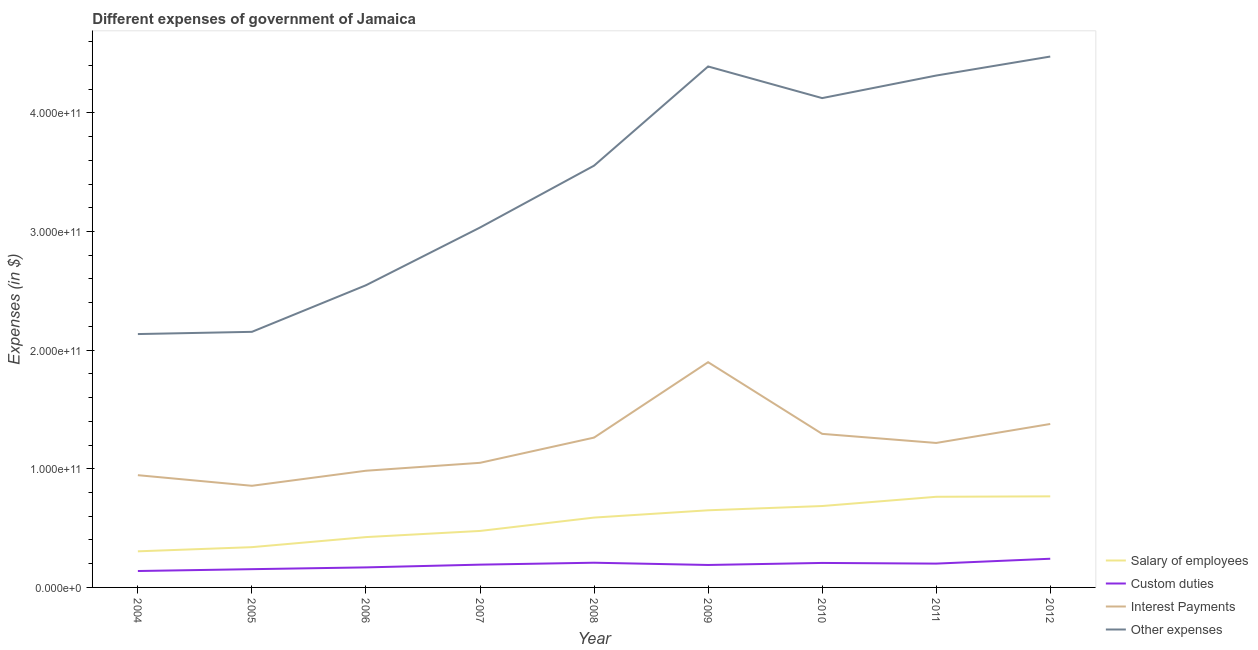Does the line corresponding to amount spent on other expenses intersect with the line corresponding to amount spent on salary of employees?
Provide a succinct answer. No. Is the number of lines equal to the number of legend labels?
Provide a succinct answer. Yes. What is the amount spent on interest payments in 2008?
Provide a succinct answer. 1.26e+11. Across all years, what is the maximum amount spent on custom duties?
Provide a succinct answer. 2.42e+1. Across all years, what is the minimum amount spent on salary of employees?
Keep it short and to the point. 3.04e+1. In which year was the amount spent on other expenses minimum?
Offer a terse response. 2004. What is the total amount spent on interest payments in the graph?
Provide a short and direct response. 1.09e+12. What is the difference between the amount spent on other expenses in 2006 and that in 2007?
Make the answer very short. -4.86e+1. What is the difference between the amount spent on custom duties in 2011 and the amount spent on other expenses in 2005?
Provide a short and direct response. -1.95e+11. What is the average amount spent on custom duties per year?
Ensure brevity in your answer.  1.89e+1. In the year 2007, what is the difference between the amount spent on interest payments and amount spent on other expenses?
Give a very brief answer. -1.98e+11. In how many years, is the amount spent on other expenses greater than 300000000000 $?
Make the answer very short. 6. What is the ratio of the amount spent on other expenses in 2011 to that in 2012?
Ensure brevity in your answer.  0.96. Is the amount spent on interest payments in 2005 less than that in 2009?
Offer a very short reply. Yes. Is the difference between the amount spent on other expenses in 2005 and 2009 greater than the difference between the amount spent on salary of employees in 2005 and 2009?
Provide a short and direct response. No. What is the difference between the highest and the second highest amount spent on interest payments?
Provide a succinct answer. 5.21e+1. What is the difference between the highest and the lowest amount spent on other expenses?
Offer a very short reply. 2.34e+11. In how many years, is the amount spent on other expenses greater than the average amount spent on other expenses taken over all years?
Your response must be concise. 5. Does the amount spent on salary of employees monotonically increase over the years?
Ensure brevity in your answer.  Yes. Is the amount spent on custom duties strictly greater than the amount spent on other expenses over the years?
Provide a succinct answer. No. Is the amount spent on other expenses strictly less than the amount spent on salary of employees over the years?
Provide a short and direct response. No. How many years are there in the graph?
Keep it short and to the point. 9. What is the difference between two consecutive major ticks on the Y-axis?
Your answer should be very brief. 1.00e+11. How are the legend labels stacked?
Your answer should be very brief. Vertical. What is the title of the graph?
Offer a very short reply. Different expenses of government of Jamaica. Does "Social equity" appear as one of the legend labels in the graph?
Your answer should be very brief. No. What is the label or title of the Y-axis?
Provide a short and direct response. Expenses (in $). What is the Expenses (in $) of Salary of employees in 2004?
Ensure brevity in your answer.  3.04e+1. What is the Expenses (in $) in Custom duties in 2004?
Ensure brevity in your answer.  1.38e+1. What is the Expenses (in $) in Interest Payments in 2004?
Offer a terse response. 9.46e+1. What is the Expenses (in $) in Other expenses in 2004?
Provide a succinct answer. 2.14e+11. What is the Expenses (in $) of Salary of employees in 2005?
Make the answer very short. 3.39e+1. What is the Expenses (in $) in Custom duties in 2005?
Offer a terse response. 1.54e+1. What is the Expenses (in $) in Interest Payments in 2005?
Ensure brevity in your answer.  8.57e+1. What is the Expenses (in $) in Other expenses in 2005?
Offer a terse response. 2.15e+11. What is the Expenses (in $) of Salary of employees in 2006?
Your response must be concise. 4.24e+1. What is the Expenses (in $) of Custom duties in 2006?
Offer a very short reply. 1.69e+1. What is the Expenses (in $) in Interest Payments in 2006?
Give a very brief answer. 9.84e+1. What is the Expenses (in $) of Other expenses in 2006?
Keep it short and to the point. 2.55e+11. What is the Expenses (in $) in Salary of employees in 2007?
Keep it short and to the point. 4.76e+1. What is the Expenses (in $) in Custom duties in 2007?
Your response must be concise. 1.92e+1. What is the Expenses (in $) in Interest Payments in 2007?
Your answer should be very brief. 1.05e+11. What is the Expenses (in $) in Other expenses in 2007?
Offer a terse response. 3.03e+11. What is the Expenses (in $) of Salary of employees in 2008?
Keep it short and to the point. 5.89e+1. What is the Expenses (in $) of Custom duties in 2008?
Give a very brief answer. 2.08e+1. What is the Expenses (in $) in Interest Payments in 2008?
Offer a very short reply. 1.26e+11. What is the Expenses (in $) of Other expenses in 2008?
Offer a terse response. 3.55e+11. What is the Expenses (in $) in Salary of employees in 2009?
Provide a succinct answer. 6.50e+1. What is the Expenses (in $) of Custom duties in 2009?
Your answer should be very brief. 1.89e+1. What is the Expenses (in $) in Interest Payments in 2009?
Give a very brief answer. 1.90e+11. What is the Expenses (in $) in Other expenses in 2009?
Give a very brief answer. 4.39e+11. What is the Expenses (in $) of Salary of employees in 2010?
Provide a succinct answer. 6.86e+1. What is the Expenses (in $) of Custom duties in 2010?
Your answer should be very brief. 2.06e+1. What is the Expenses (in $) in Interest Payments in 2010?
Offer a terse response. 1.29e+11. What is the Expenses (in $) in Other expenses in 2010?
Offer a terse response. 4.12e+11. What is the Expenses (in $) in Salary of employees in 2011?
Ensure brevity in your answer.  7.64e+1. What is the Expenses (in $) in Custom duties in 2011?
Give a very brief answer. 2.01e+1. What is the Expenses (in $) of Interest Payments in 2011?
Your response must be concise. 1.22e+11. What is the Expenses (in $) of Other expenses in 2011?
Keep it short and to the point. 4.31e+11. What is the Expenses (in $) in Salary of employees in 2012?
Your answer should be compact. 7.68e+1. What is the Expenses (in $) of Custom duties in 2012?
Provide a short and direct response. 2.42e+1. What is the Expenses (in $) of Interest Payments in 2012?
Offer a very short reply. 1.38e+11. What is the Expenses (in $) in Other expenses in 2012?
Provide a succinct answer. 4.47e+11. Across all years, what is the maximum Expenses (in $) of Salary of employees?
Provide a short and direct response. 7.68e+1. Across all years, what is the maximum Expenses (in $) of Custom duties?
Ensure brevity in your answer.  2.42e+1. Across all years, what is the maximum Expenses (in $) in Interest Payments?
Ensure brevity in your answer.  1.90e+11. Across all years, what is the maximum Expenses (in $) of Other expenses?
Provide a short and direct response. 4.47e+11. Across all years, what is the minimum Expenses (in $) in Salary of employees?
Your answer should be very brief. 3.04e+1. Across all years, what is the minimum Expenses (in $) of Custom duties?
Your response must be concise. 1.38e+1. Across all years, what is the minimum Expenses (in $) of Interest Payments?
Provide a short and direct response. 8.57e+1. Across all years, what is the minimum Expenses (in $) in Other expenses?
Provide a short and direct response. 2.14e+11. What is the total Expenses (in $) of Salary of employees in the graph?
Your response must be concise. 5.00e+11. What is the total Expenses (in $) of Custom duties in the graph?
Provide a short and direct response. 1.70e+11. What is the total Expenses (in $) in Interest Payments in the graph?
Give a very brief answer. 1.09e+12. What is the total Expenses (in $) of Other expenses in the graph?
Make the answer very short. 3.07e+12. What is the difference between the Expenses (in $) of Salary of employees in 2004 and that in 2005?
Your response must be concise. -3.52e+09. What is the difference between the Expenses (in $) in Custom duties in 2004 and that in 2005?
Ensure brevity in your answer.  -1.56e+09. What is the difference between the Expenses (in $) of Interest Payments in 2004 and that in 2005?
Provide a short and direct response. 8.94e+09. What is the difference between the Expenses (in $) of Other expenses in 2004 and that in 2005?
Your response must be concise. -1.88e+09. What is the difference between the Expenses (in $) of Salary of employees in 2004 and that in 2006?
Offer a terse response. -1.20e+1. What is the difference between the Expenses (in $) of Custom duties in 2004 and that in 2006?
Offer a terse response. -3.05e+09. What is the difference between the Expenses (in $) of Interest Payments in 2004 and that in 2006?
Give a very brief answer. -3.75e+09. What is the difference between the Expenses (in $) in Other expenses in 2004 and that in 2006?
Your answer should be very brief. -4.11e+1. What is the difference between the Expenses (in $) in Salary of employees in 2004 and that in 2007?
Provide a succinct answer. -1.72e+1. What is the difference between the Expenses (in $) in Custom duties in 2004 and that in 2007?
Offer a very short reply. -5.38e+09. What is the difference between the Expenses (in $) in Interest Payments in 2004 and that in 2007?
Provide a succinct answer. -1.04e+1. What is the difference between the Expenses (in $) in Other expenses in 2004 and that in 2007?
Offer a very short reply. -8.98e+1. What is the difference between the Expenses (in $) in Salary of employees in 2004 and that in 2008?
Keep it short and to the point. -2.84e+1. What is the difference between the Expenses (in $) in Custom duties in 2004 and that in 2008?
Your answer should be very brief. -6.99e+09. What is the difference between the Expenses (in $) of Interest Payments in 2004 and that in 2008?
Offer a very short reply. -3.17e+1. What is the difference between the Expenses (in $) of Other expenses in 2004 and that in 2008?
Make the answer very short. -1.42e+11. What is the difference between the Expenses (in $) of Salary of employees in 2004 and that in 2009?
Provide a short and direct response. -3.46e+1. What is the difference between the Expenses (in $) of Custom duties in 2004 and that in 2009?
Keep it short and to the point. -5.10e+09. What is the difference between the Expenses (in $) of Interest Payments in 2004 and that in 2009?
Ensure brevity in your answer.  -9.52e+1. What is the difference between the Expenses (in $) of Other expenses in 2004 and that in 2009?
Offer a terse response. -2.26e+11. What is the difference between the Expenses (in $) in Salary of employees in 2004 and that in 2010?
Your answer should be very brief. -3.82e+1. What is the difference between the Expenses (in $) in Custom duties in 2004 and that in 2010?
Provide a succinct answer. -6.82e+09. What is the difference between the Expenses (in $) of Interest Payments in 2004 and that in 2010?
Provide a short and direct response. -3.48e+1. What is the difference between the Expenses (in $) of Other expenses in 2004 and that in 2010?
Provide a short and direct response. -1.99e+11. What is the difference between the Expenses (in $) of Salary of employees in 2004 and that in 2011?
Give a very brief answer. -4.60e+1. What is the difference between the Expenses (in $) in Custom duties in 2004 and that in 2011?
Ensure brevity in your answer.  -6.25e+09. What is the difference between the Expenses (in $) of Interest Payments in 2004 and that in 2011?
Ensure brevity in your answer.  -2.72e+1. What is the difference between the Expenses (in $) in Other expenses in 2004 and that in 2011?
Ensure brevity in your answer.  -2.18e+11. What is the difference between the Expenses (in $) in Salary of employees in 2004 and that in 2012?
Ensure brevity in your answer.  -4.63e+1. What is the difference between the Expenses (in $) in Custom duties in 2004 and that in 2012?
Your response must be concise. -1.03e+1. What is the difference between the Expenses (in $) of Interest Payments in 2004 and that in 2012?
Offer a terse response. -4.31e+1. What is the difference between the Expenses (in $) in Other expenses in 2004 and that in 2012?
Provide a succinct answer. -2.34e+11. What is the difference between the Expenses (in $) in Salary of employees in 2005 and that in 2006?
Offer a terse response. -8.48e+09. What is the difference between the Expenses (in $) in Custom duties in 2005 and that in 2006?
Offer a very short reply. -1.49e+09. What is the difference between the Expenses (in $) of Interest Payments in 2005 and that in 2006?
Make the answer very short. -1.27e+1. What is the difference between the Expenses (in $) in Other expenses in 2005 and that in 2006?
Your response must be concise. -3.93e+1. What is the difference between the Expenses (in $) in Salary of employees in 2005 and that in 2007?
Keep it short and to the point. -1.37e+1. What is the difference between the Expenses (in $) in Custom duties in 2005 and that in 2007?
Keep it short and to the point. -3.82e+09. What is the difference between the Expenses (in $) in Interest Payments in 2005 and that in 2007?
Your answer should be very brief. -1.94e+1. What is the difference between the Expenses (in $) in Other expenses in 2005 and that in 2007?
Provide a succinct answer. -8.79e+1. What is the difference between the Expenses (in $) of Salary of employees in 2005 and that in 2008?
Your response must be concise. -2.49e+1. What is the difference between the Expenses (in $) in Custom duties in 2005 and that in 2008?
Ensure brevity in your answer.  -5.44e+09. What is the difference between the Expenses (in $) of Interest Payments in 2005 and that in 2008?
Keep it short and to the point. -4.06e+1. What is the difference between the Expenses (in $) of Other expenses in 2005 and that in 2008?
Offer a terse response. -1.40e+11. What is the difference between the Expenses (in $) in Salary of employees in 2005 and that in 2009?
Offer a very short reply. -3.11e+1. What is the difference between the Expenses (in $) of Custom duties in 2005 and that in 2009?
Your answer should be compact. -3.54e+09. What is the difference between the Expenses (in $) in Interest Payments in 2005 and that in 2009?
Offer a very short reply. -1.04e+11. What is the difference between the Expenses (in $) in Other expenses in 2005 and that in 2009?
Your answer should be compact. -2.24e+11. What is the difference between the Expenses (in $) in Salary of employees in 2005 and that in 2010?
Provide a short and direct response. -3.47e+1. What is the difference between the Expenses (in $) of Custom duties in 2005 and that in 2010?
Your response must be concise. -5.26e+09. What is the difference between the Expenses (in $) of Interest Payments in 2005 and that in 2010?
Provide a short and direct response. -4.38e+1. What is the difference between the Expenses (in $) in Other expenses in 2005 and that in 2010?
Give a very brief answer. -1.97e+11. What is the difference between the Expenses (in $) of Salary of employees in 2005 and that in 2011?
Provide a short and direct response. -4.24e+1. What is the difference between the Expenses (in $) in Custom duties in 2005 and that in 2011?
Keep it short and to the point. -4.69e+09. What is the difference between the Expenses (in $) of Interest Payments in 2005 and that in 2011?
Provide a succinct answer. -3.61e+1. What is the difference between the Expenses (in $) of Other expenses in 2005 and that in 2011?
Provide a succinct answer. -2.16e+11. What is the difference between the Expenses (in $) of Salary of employees in 2005 and that in 2012?
Ensure brevity in your answer.  -4.28e+1. What is the difference between the Expenses (in $) of Custom duties in 2005 and that in 2012?
Ensure brevity in your answer.  -8.79e+09. What is the difference between the Expenses (in $) of Interest Payments in 2005 and that in 2012?
Make the answer very short. -5.21e+1. What is the difference between the Expenses (in $) of Other expenses in 2005 and that in 2012?
Offer a very short reply. -2.32e+11. What is the difference between the Expenses (in $) of Salary of employees in 2006 and that in 2007?
Your answer should be compact. -5.18e+09. What is the difference between the Expenses (in $) in Custom duties in 2006 and that in 2007?
Provide a succinct answer. -2.33e+09. What is the difference between the Expenses (in $) of Interest Payments in 2006 and that in 2007?
Provide a succinct answer. -6.67e+09. What is the difference between the Expenses (in $) in Other expenses in 2006 and that in 2007?
Your response must be concise. -4.86e+1. What is the difference between the Expenses (in $) of Salary of employees in 2006 and that in 2008?
Provide a succinct answer. -1.64e+1. What is the difference between the Expenses (in $) of Custom duties in 2006 and that in 2008?
Your answer should be very brief. -3.94e+09. What is the difference between the Expenses (in $) in Interest Payments in 2006 and that in 2008?
Make the answer very short. -2.79e+1. What is the difference between the Expenses (in $) of Other expenses in 2006 and that in 2008?
Provide a succinct answer. -1.01e+11. What is the difference between the Expenses (in $) in Salary of employees in 2006 and that in 2009?
Keep it short and to the point. -2.26e+1. What is the difference between the Expenses (in $) in Custom duties in 2006 and that in 2009?
Your answer should be very brief. -2.05e+09. What is the difference between the Expenses (in $) of Interest Payments in 2006 and that in 2009?
Your answer should be compact. -9.15e+1. What is the difference between the Expenses (in $) in Other expenses in 2006 and that in 2009?
Your response must be concise. -1.84e+11. What is the difference between the Expenses (in $) in Salary of employees in 2006 and that in 2010?
Offer a very short reply. -2.62e+1. What is the difference between the Expenses (in $) of Custom duties in 2006 and that in 2010?
Provide a succinct answer. -3.76e+09. What is the difference between the Expenses (in $) in Interest Payments in 2006 and that in 2010?
Your answer should be very brief. -3.11e+1. What is the difference between the Expenses (in $) in Other expenses in 2006 and that in 2010?
Offer a terse response. -1.58e+11. What is the difference between the Expenses (in $) in Salary of employees in 2006 and that in 2011?
Provide a succinct answer. -3.40e+1. What is the difference between the Expenses (in $) in Custom duties in 2006 and that in 2011?
Provide a short and direct response. -3.19e+09. What is the difference between the Expenses (in $) of Interest Payments in 2006 and that in 2011?
Ensure brevity in your answer.  -2.34e+1. What is the difference between the Expenses (in $) in Other expenses in 2006 and that in 2011?
Your answer should be very brief. -1.77e+11. What is the difference between the Expenses (in $) in Salary of employees in 2006 and that in 2012?
Make the answer very short. -3.43e+1. What is the difference between the Expenses (in $) in Custom duties in 2006 and that in 2012?
Offer a terse response. -7.29e+09. What is the difference between the Expenses (in $) in Interest Payments in 2006 and that in 2012?
Offer a terse response. -3.94e+1. What is the difference between the Expenses (in $) in Other expenses in 2006 and that in 2012?
Your response must be concise. -1.93e+11. What is the difference between the Expenses (in $) in Salary of employees in 2007 and that in 2008?
Keep it short and to the point. -1.13e+1. What is the difference between the Expenses (in $) of Custom duties in 2007 and that in 2008?
Ensure brevity in your answer.  -1.62e+09. What is the difference between the Expenses (in $) in Interest Payments in 2007 and that in 2008?
Your response must be concise. -2.13e+1. What is the difference between the Expenses (in $) of Other expenses in 2007 and that in 2008?
Your response must be concise. -5.21e+1. What is the difference between the Expenses (in $) of Salary of employees in 2007 and that in 2009?
Provide a short and direct response. -1.74e+1. What is the difference between the Expenses (in $) in Custom duties in 2007 and that in 2009?
Your answer should be very brief. 2.75e+08. What is the difference between the Expenses (in $) in Interest Payments in 2007 and that in 2009?
Your answer should be compact. -8.48e+1. What is the difference between the Expenses (in $) of Other expenses in 2007 and that in 2009?
Provide a short and direct response. -1.36e+11. What is the difference between the Expenses (in $) of Salary of employees in 2007 and that in 2010?
Offer a terse response. -2.10e+1. What is the difference between the Expenses (in $) of Custom duties in 2007 and that in 2010?
Make the answer very short. -1.44e+09. What is the difference between the Expenses (in $) of Interest Payments in 2007 and that in 2010?
Your answer should be very brief. -2.44e+1. What is the difference between the Expenses (in $) in Other expenses in 2007 and that in 2010?
Give a very brief answer. -1.09e+11. What is the difference between the Expenses (in $) of Salary of employees in 2007 and that in 2011?
Your response must be concise. -2.88e+1. What is the difference between the Expenses (in $) of Custom duties in 2007 and that in 2011?
Provide a succinct answer. -8.66e+08. What is the difference between the Expenses (in $) of Interest Payments in 2007 and that in 2011?
Offer a terse response. -1.67e+1. What is the difference between the Expenses (in $) of Other expenses in 2007 and that in 2011?
Your answer should be compact. -1.28e+11. What is the difference between the Expenses (in $) of Salary of employees in 2007 and that in 2012?
Give a very brief answer. -2.92e+1. What is the difference between the Expenses (in $) of Custom duties in 2007 and that in 2012?
Offer a very short reply. -4.97e+09. What is the difference between the Expenses (in $) of Interest Payments in 2007 and that in 2012?
Provide a short and direct response. -3.27e+1. What is the difference between the Expenses (in $) in Other expenses in 2007 and that in 2012?
Ensure brevity in your answer.  -1.44e+11. What is the difference between the Expenses (in $) in Salary of employees in 2008 and that in 2009?
Provide a succinct answer. -6.14e+09. What is the difference between the Expenses (in $) in Custom duties in 2008 and that in 2009?
Your answer should be compact. 1.89e+09. What is the difference between the Expenses (in $) in Interest Payments in 2008 and that in 2009?
Offer a terse response. -6.36e+1. What is the difference between the Expenses (in $) in Other expenses in 2008 and that in 2009?
Give a very brief answer. -8.36e+1. What is the difference between the Expenses (in $) in Salary of employees in 2008 and that in 2010?
Your answer should be compact. -9.73e+09. What is the difference between the Expenses (in $) of Custom duties in 2008 and that in 2010?
Offer a terse response. 1.80e+08. What is the difference between the Expenses (in $) in Interest Payments in 2008 and that in 2010?
Offer a very short reply. -3.15e+09. What is the difference between the Expenses (in $) in Other expenses in 2008 and that in 2010?
Your answer should be very brief. -5.69e+1. What is the difference between the Expenses (in $) in Salary of employees in 2008 and that in 2011?
Make the answer very short. -1.75e+1. What is the difference between the Expenses (in $) in Custom duties in 2008 and that in 2011?
Ensure brevity in your answer.  7.50e+08. What is the difference between the Expenses (in $) of Interest Payments in 2008 and that in 2011?
Your response must be concise. 4.51e+09. What is the difference between the Expenses (in $) in Other expenses in 2008 and that in 2011?
Your answer should be very brief. -7.60e+1. What is the difference between the Expenses (in $) of Salary of employees in 2008 and that in 2012?
Provide a succinct answer. -1.79e+1. What is the difference between the Expenses (in $) of Custom duties in 2008 and that in 2012?
Ensure brevity in your answer.  -3.35e+09. What is the difference between the Expenses (in $) of Interest Payments in 2008 and that in 2012?
Ensure brevity in your answer.  -1.15e+1. What is the difference between the Expenses (in $) in Other expenses in 2008 and that in 2012?
Offer a terse response. -9.20e+1. What is the difference between the Expenses (in $) in Salary of employees in 2009 and that in 2010?
Ensure brevity in your answer.  -3.59e+09. What is the difference between the Expenses (in $) in Custom duties in 2009 and that in 2010?
Your response must be concise. -1.71e+09. What is the difference between the Expenses (in $) in Interest Payments in 2009 and that in 2010?
Make the answer very short. 6.04e+1. What is the difference between the Expenses (in $) of Other expenses in 2009 and that in 2010?
Give a very brief answer. 2.67e+1. What is the difference between the Expenses (in $) of Salary of employees in 2009 and that in 2011?
Provide a short and direct response. -1.14e+1. What is the difference between the Expenses (in $) of Custom duties in 2009 and that in 2011?
Make the answer very short. -1.14e+09. What is the difference between the Expenses (in $) of Interest Payments in 2009 and that in 2011?
Give a very brief answer. 6.81e+1. What is the difference between the Expenses (in $) in Other expenses in 2009 and that in 2011?
Your answer should be compact. 7.65e+09. What is the difference between the Expenses (in $) in Salary of employees in 2009 and that in 2012?
Give a very brief answer. -1.18e+1. What is the difference between the Expenses (in $) of Custom duties in 2009 and that in 2012?
Your response must be concise. -5.24e+09. What is the difference between the Expenses (in $) of Interest Payments in 2009 and that in 2012?
Provide a succinct answer. 5.21e+1. What is the difference between the Expenses (in $) of Other expenses in 2009 and that in 2012?
Give a very brief answer. -8.36e+09. What is the difference between the Expenses (in $) in Salary of employees in 2010 and that in 2011?
Your response must be concise. -7.79e+09. What is the difference between the Expenses (in $) in Custom duties in 2010 and that in 2011?
Make the answer very short. 5.70e+08. What is the difference between the Expenses (in $) of Interest Payments in 2010 and that in 2011?
Your answer should be compact. 7.67e+09. What is the difference between the Expenses (in $) of Other expenses in 2010 and that in 2011?
Your answer should be compact. -1.90e+1. What is the difference between the Expenses (in $) of Salary of employees in 2010 and that in 2012?
Give a very brief answer. -8.17e+09. What is the difference between the Expenses (in $) of Custom duties in 2010 and that in 2012?
Provide a short and direct response. -3.53e+09. What is the difference between the Expenses (in $) of Interest Payments in 2010 and that in 2012?
Give a very brief answer. -8.32e+09. What is the difference between the Expenses (in $) of Other expenses in 2010 and that in 2012?
Give a very brief answer. -3.50e+1. What is the difference between the Expenses (in $) of Salary of employees in 2011 and that in 2012?
Keep it short and to the point. -3.74e+08. What is the difference between the Expenses (in $) in Custom duties in 2011 and that in 2012?
Your response must be concise. -4.10e+09. What is the difference between the Expenses (in $) of Interest Payments in 2011 and that in 2012?
Make the answer very short. -1.60e+1. What is the difference between the Expenses (in $) in Other expenses in 2011 and that in 2012?
Your response must be concise. -1.60e+1. What is the difference between the Expenses (in $) of Salary of employees in 2004 and the Expenses (in $) of Custom duties in 2005?
Keep it short and to the point. 1.50e+1. What is the difference between the Expenses (in $) of Salary of employees in 2004 and the Expenses (in $) of Interest Payments in 2005?
Make the answer very short. -5.52e+1. What is the difference between the Expenses (in $) in Salary of employees in 2004 and the Expenses (in $) in Other expenses in 2005?
Your answer should be compact. -1.85e+11. What is the difference between the Expenses (in $) of Custom duties in 2004 and the Expenses (in $) of Interest Payments in 2005?
Your answer should be compact. -7.18e+1. What is the difference between the Expenses (in $) in Custom duties in 2004 and the Expenses (in $) in Other expenses in 2005?
Keep it short and to the point. -2.02e+11. What is the difference between the Expenses (in $) in Interest Payments in 2004 and the Expenses (in $) in Other expenses in 2005?
Your answer should be very brief. -1.21e+11. What is the difference between the Expenses (in $) in Salary of employees in 2004 and the Expenses (in $) in Custom duties in 2006?
Offer a very short reply. 1.35e+1. What is the difference between the Expenses (in $) of Salary of employees in 2004 and the Expenses (in $) of Interest Payments in 2006?
Make the answer very short. -6.79e+1. What is the difference between the Expenses (in $) of Salary of employees in 2004 and the Expenses (in $) of Other expenses in 2006?
Offer a terse response. -2.24e+11. What is the difference between the Expenses (in $) of Custom duties in 2004 and the Expenses (in $) of Interest Payments in 2006?
Offer a terse response. -8.45e+1. What is the difference between the Expenses (in $) in Custom duties in 2004 and the Expenses (in $) in Other expenses in 2006?
Ensure brevity in your answer.  -2.41e+11. What is the difference between the Expenses (in $) in Interest Payments in 2004 and the Expenses (in $) in Other expenses in 2006?
Your response must be concise. -1.60e+11. What is the difference between the Expenses (in $) in Salary of employees in 2004 and the Expenses (in $) in Custom duties in 2007?
Offer a terse response. 1.12e+1. What is the difference between the Expenses (in $) of Salary of employees in 2004 and the Expenses (in $) of Interest Payments in 2007?
Give a very brief answer. -7.46e+1. What is the difference between the Expenses (in $) of Salary of employees in 2004 and the Expenses (in $) of Other expenses in 2007?
Offer a very short reply. -2.73e+11. What is the difference between the Expenses (in $) in Custom duties in 2004 and the Expenses (in $) in Interest Payments in 2007?
Give a very brief answer. -9.12e+1. What is the difference between the Expenses (in $) of Custom duties in 2004 and the Expenses (in $) of Other expenses in 2007?
Ensure brevity in your answer.  -2.90e+11. What is the difference between the Expenses (in $) of Interest Payments in 2004 and the Expenses (in $) of Other expenses in 2007?
Give a very brief answer. -2.09e+11. What is the difference between the Expenses (in $) of Salary of employees in 2004 and the Expenses (in $) of Custom duties in 2008?
Offer a terse response. 9.60e+09. What is the difference between the Expenses (in $) in Salary of employees in 2004 and the Expenses (in $) in Interest Payments in 2008?
Make the answer very short. -9.59e+1. What is the difference between the Expenses (in $) in Salary of employees in 2004 and the Expenses (in $) in Other expenses in 2008?
Offer a very short reply. -3.25e+11. What is the difference between the Expenses (in $) of Custom duties in 2004 and the Expenses (in $) of Interest Payments in 2008?
Provide a short and direct response. -1.12e+11. What is the difference between the Expenses (in $) in Custom duties in 2004 and the Expenses (in $) in Other expenses in 2008?
Keep it short and to the point. -3.42e+11. What is the difference between the Expenses (in $) in Interest Payments in 2004 and the Expenses (in $) in Other expenses in 2008?
Provide a short and direct response. -2.61e+11. What is the difference between the Expenses (in $) of Salary of employees in 2004 and the Expenses (in $) of Custom duties in 2009?
Provide a short and direct response. 1.15e+1. What is the difference between the Expenses (in $) in Salary of employees in 2004 and the Expenses (in $) in Interest Payments in 2009?
Keep it short and to the point. -1.59e+11. What is the difference between the Expenses (in $) of Salary of employees in 2004 and the Expenses (in $) of Other expenses in 2009?
Your answer should be compact. -4.09e+11. What is the difference between the Expenses (in $) of Custom duties in 2004 and the Expenses (in $) of Interest Payments in 2009?
Provide a succinct answer. -1.76e+11. What is the difference between the Expenses (in $) in Custom duties in 2004 and the Expenses (in $) in Other expenses in 2009?
Ensure brevity in your answer.  -4.25e+11. What is the difference between the Expenses (in $) in Interest Payments in 2004 and the Expenses (in $) in Other expenses in 2009?
Your response must be concise. -3.44e+11. What is the difference between the Expenses (in $) in Salary of employees in 2004 and the Expenses (in $) in Custom duties in 2010?
Keep it short and to the point. 9.78e+09. What is the difference between the Expenses (in $) in Salary of employees in 2004 and the Expenses (in $) in Interest Payments in 2010?
Your answer should be compact. -9.90e+1. What is the difference between the Expenses (in $) of Salary of employees in 2004 and the Expenses (in $) of Other expenses in 2010?
Provide a short and direct response. -3.82e+11. What is the difference between the Expenses (in $) in Custom duties in 2004 and the Expenses (in $) in Interest Payments in 2010?
Offer a very short reply. -1.16e+11. What is the difference between the Expenses (in $) in Custom duties in 2004 and the Expenses (in $) in Other expenses in 2010?
Ensure brevity in your answer.  -3.99e+11. What is the difference between the Expenses (in $) in Interest Payments in 2004 and the Expenses (in $) in Other expenses in 2010?
Your response must be concise. -3.18e+11. What is the difference between the Expenses (in $) of Salary of employees in 2004 and the Expenses (in $) of Custom duties in 2011?
Your answer should be compact. 1.04e+1. What is the difference between the Expenses (in $) in Salary of employees in 2004 and the Expenses (in $) in Interest Payments in 2011?
Provide a short and direct response. -9.13e+1. What is the difference between the Expenses (in $) in Salary of employees in 2004 and the Expenses (in $) in Other expenses in 2011?
Provide a succinct answer. -4.01e+11. What is the difference between the Expenses (in $) of Custom duties in 2004 and the Expenses (in $) of Interest Payments in 2011?
Offer a terse response. -1.08e+11. What is the difference between the Expenses (in $) in Custom duties in 2004 and the Expenses (in $) in Other expenses in 2011?
Provide a succinct answer. -4.18e+11. What is the difference between the Expenses (in $) of Interest Payments in 2004 and the Expenses (in $) of Other expenses in 2011?
Offer a very short reply. -3.37e+11. What is the difference between the Expenses (in $) of Salary of employees in 2004 and the Expenses (in $) of Custom duties in 2012?
Provide a short and direct response. 6.25e+09. What is the difference between the Expenses (in $) of Salary of employees in 2004 and the Expenses (in $) of Interest Payments in 2012?
Your response must be concise. -1.07e+11. What is the difference between the Expenses (in $) of Salary of employees in 2004 and the Expenses (in $) of Other expenses in 2012?
Ensure brevity in your answer.  -4.17e+11. What is the difference between the Expenses (in $) in Custom duties in 2004 and the Expenses (in $) in Interest Payments in 2012?
Make the answer very short. -1.24e+11. What is the difference between the Expenses (in $) of Custom duties in 2004 and the Expenses (in $) of Other expenses in 2012?
Your answer should be very brief. -4.34e+11. What is the difference between the Expenses (in $) in Interest Payments in 2004 and the Expenses (in $) in Other expenses in 2012?
Offer a terse response. -3.53e+11. What is the difference between the Expenses (in $) of Salary of employees in 2005 and the Expenses (in $) of Custom duties in 2006?
Offer a terse response. 1.71e+1. What is the difference between the Expenses (in $) in Salary of employees in 2005 and the Expenses (in $) in Interest Payments in 2006?
Your response must be concise. -6.44e+1. What is the difference between the Expenses (in $) in Salary of employees in 2005 and the Expenses (in $) in Other expenses in 2006?
Make the answer very short. -2.21e+11. What is the difference between the Expenses (in $) in Custom duties in 2005 and the Expenses (in $) in Interest Payments in 2006?
Your answer should be compact. -8.30e+1. What is the difference between the Expenses (in $) in Custom duties in 2005 and the Expenses (in $) in Other expenses in 2006?
Your answer should be very brief. -2.39e+11. What is the difference between the Expenses (in $) in Interest Payments in 2005 and the Expenses (in $) in Other expenses in 2006?
Keep it short and to the point. -1.69e+11. What is the difference between the Expenses (in $) in Salary of employees in 2005 and the Expenses (in $) in Custom duties in 2007?
Your answer should be compact. 1.47e+1. What is the difference between the Expenses (in $) in Salary of employees in 2005 and the Expenses (in $) in Interest Payments in 2007?
Make the answer very short. -7.11e+1. What is the difference between the Expenses (in $) of Salary of employees in 2005 and the Expenses (in $) of Other expenses in 2007?
Your answer should be very brief. -2.69e+11. What is the difference between the Expenses (in $) in Custom duties in 2005 and the Expenses (in $) in Interest Payments in 2007?
Provide a succinct answer. -8.96e+1. What is the difference between the Expenses (in $) of Custom duties in 2005 and the Expenses (in $) of Other expenses in 2007?
Keep it short and to the point. -2.88e+11. What is the difference between the Expenses (in $) in Interest Payments in 2005 and the Expenses (in $) in Other expenses in 2007?
Your answer should be compact. -2.18e+11. What is the difference between the Expenses (in $) in Salary of employees in 2005 and the Expenses (in $) in Custom duties in 2008?
Your answer should be compact. 1.31e+1. What is the difference between the Expenses (in $) of Salary of employees in 2005 and the Expenses (in $) of Interest Payments in 2008?
Offer a terse response. -9.23e+1. What is the difference between the Expenses (in $) of Salary of employees in 2005 and the Expenses (in $) of Other expenses in 2008?
Give a very brief answer. -3.22e+11. What is the difference between the Expenses (in $) in Custom duties in 2005 and the Expenses (in $) in Interest Payments in 2008?
Give a very brief answer. -1.11e+11. What is the difference between the Expenses (in $) of Custom duties in 2005 and the Expenses (in $) of Other expenses in 2008?
Make the answer very short. -3.40e+11. What is the difference between the Expenses (in $) in Interest Payments in 2005 and the Expenses (in $) in Other expenses in 2008?
Ensure brevity in your answer.  -2.70e+11. What is the difference between the Expenses (in $) in Salary of employees in 2005 and the Expenses (in $) in Custom duties in 2009?
Ensure brevity in your answer.  1.50e+1. What is the difference between the Expenses (in $) in Salary of employees in 2005 and the Expenses (in $) in Interest Payments in 2009?
Provide a short and direct response. -1.56e+11. What is the difference between the Expenses (in $) in Salary of employees in 2005 and the Expenses (in $) in Other expenses in 2009?
Keep it short and to the point. -4.05e+11. What is the difference between the Expenses (in $) of Custom duties in 2005 and the Expenses (in $) of Interest Payments in 2009?
Your answer should be compact. -1.74e+11. What is the difference between the Expenses (in $) of Custom duties in 2005 and the Expenses (in $) of Other expenses in 2009?
Ensure brevity in your answer.  -4.24e+11. What is the difference between the Expenses (in $) of Interest Payments in 2005 and the Expenses (in $) of Other expenses in 2009?
Keep it short and to the point. -3.53e+11. What is the difference between the Expenses (in $) of Salary of employees in 2005 and the Expenses (in $) of Custom duties in 2010?
Offer a terse response. 1.33e+1. What is the difference between the Expenses (in $) in Salary of employees in 2005 and the Expenses (in $) in Interest Payments in 2010?
Your answer should be compact. -9.55e+1. What is the difference between the Expenses (in $) of Salary of employees in 2005 and the Expenses (in $) of Other expenses in 2010?
Offer a terse response. -3.78e+11. What is the difference between the Expenses (in $) in Custom duties in 2005 and the Expenses (in $) in Interest Payments in 2010?
Offer a terse response. -1.14e+11. What is the difference between the Expenses (in $) in Custom duties in 2005 and the Expenses (in $) in Other expenses in 2010?
Provide a short and direct response. -3.97e+11. What is the difference between the Expenses (in $) in Interest Payments in 2005 and the Expenses (in $) in Other expenses in 2010?
Offer a terse response. -3.27e+11. What is the difference between the Expenses (in $) in Salary of employees in 2005 and the Expenses (in $) in Custom duties in 2011?
Offer a terse response. 1.39e+1. What is the difference between the Expenses (in $) in Salary of employees in 2005 and the Expenses (in $) in Interest Payments in 2011?
Your response must be concise. -8.78e+1. What is the difference between the Expenses (in $) of Salary of employees in 2005 and the Expenses (in $) of Other expenses in 2011?
Keep it short and to the point. -3.97e+11. What is the difference between the Expenses (in $) in Custom duties in 2005 and the Expenses (in $) in Interest Payments in 2011?
Make the answer very short. -1.06e+11. What is the difference between the Expenses (in $) of Custom duties in 2005 and the Expenses (in $) of Other expenses in 2011?
Your answer should be compact. -4.16e+11. What is the difference between the Expenses (in $) of Interest Payments in 2005 and the Expenses (in $) of Other expenses in 2011?
Ensure brevity in your answer.  -3.46e+11. What is the difference between the Expenses (in $) in Salary of employees in 2005 and the Expenses (in $) in Custom duties in 2012?
Your response must be concise. 9.77e+09. What is the difference between the Expenses (in $) of Salary of employees in 2005 and the Expenses (in $) of Interest Payments in 2012?
Your response must be concise. -1.04e+11. What is the difference between the Expenses (in $) of Salary of employees in 2005 and the Expenses (in $) of Other expenses in 2012?
Your answer should be very brief. -4.14e+11. What is the difference between the Expenses (in $) of Custom duties in 2005 and the Expenses (in $) of Interest Payments in 2012?
Offer a terse response. -1.22e+11. What is the difference between the Expenses (in $) of Custom duties in 2005 and the Expenses (in $) of Other expenses in 2012?
Give a very brief answer. -4.32e+11. What is the difference between the Expenses (in $) of Interest Payments in 2005 and the Expenses (in $) of Other expenses in 2012?
Provide a short and direct response. -3.62e+11. What is the difference between the Expenses (in $) in Salary of employees in 2006 and the Expenses (in $) in Custom duties in 2007?
Provide a short and direct response. 2.32e+1. What is the difference between the Expenses (in $) in Salary of employees in 2006 and the Expenses (in $) in Interest Payments in 2007?
Offer a very short reply. -6.26e+1. What is the difference between the Expenses (in $) in Salary of employees in 2006 and the Expenses (in $) in Other expenses in 2007?
Provide a short and direct response. -2.61e+11. What is the difference between the Expenses (in $) of Custom duties in 2006 and the Expenses (in $) of Interest Payments in 2007?
Give a very brief answer. -8.81e+1. What is the difference between the Expenses (in $) of Custom duties in 2006 and the Expenses (in $) of Other expenses in 2007?
Offer a very short reply. -2.86e+11. What is the difference between the Expenses (in $) of Interest Payments in 2006 and the Expenses (in $) of Other expenses in 2007?
Make the answer very short. -2.05e+11. What is the difference between the Expenses (in $) in Salary of employees in 2006 and the Expenses (in $) in Custom duties in 2008?
Provide a succinct answer. 2.16e+1. What is the difference between the Expenses (in $) of Salary of employees in 2006 and the Expenses (in $) of Interest Payments in 2008?
Your answer should be very brief. -8.39e+1. What is the difference between the Expenses (in $) of Salary of employees in 2006 and the Expenses (in $) of Other expenses in 2008?
Give a very brief answer. -3.13e+11. What is the difference between the Expenses (in $) of Custom duties in 2006 and the Expenses (in $) of Interest Payments in 2008?
Your answer should be compact. -1.09e+11. What is the difference between the Expenses (in $) in Custom duties in 2006 and the Expenses (in $) in Other expenses in 2008?
Make the answer very short. -3.39e+11. What is the difference between the Expenses (in $) of Interest Payments in 2006 and the Expenses (in $) of Other expenses in 2008?
Your answer should be very brief. -2.57e+11. What is the difference between the Expenses (in $) in Salary of employees in 2006 and the Expenses (in $) in Custom duties in 2009?
Your response must be concise. 2.35e+1. What is the difference between the Expenses (in $) in Salary of employees in 2006 and the Expenses (in $) in Interest Payments in 2009?
Your response must be concise. -1.47e+11. What is the difference between the Expenses (in $) of Salary of employees in 2006 and the Expenses (in $) of Other expenses in 2009?
Make the answer very short. -3.97e+11. What is the difference between the Expenses (in $) in Custom duties in 2006 and the Expenses (in $) in Interest Payments in 2009?
Provide a short and direct response. -1.73e+11. What is the difference between the Expenses (in $) of Custom duties in 2006 and the Expenses (in $) of Other expenses in 2009?
Make the answer very short. -4.22e+11. What is the difference between the Expenses (in $) of Interest Payments in 2006 and the Expenses (in $) of Other expenses in 2009?
Make the answer very short. -3.41e+11. What is the difference between the Expenses (in $) in Salary of employees in 2006 and the Expenses (in $) in Custom duties in 2010?
Your answer should be very brief. 2.18e+1. What is the difference between the Expenses (in $) of Salary of employees in 2006 and the Expenses (in $) of Interest Payments in 2010?
Offer a very short reply. -8.70e+1. What is the difference between the Expenses (in $) in Salary of employees in 2006 and the Expenses (in $) in Other expenses in 2010?
Ensure brevity in your answer.  -3.70e+11. What is the difference between the Expenses (in $) in Custom duties in 2006 and the Expenses (in $) in Interest Payments in 2010?
Offer a terse response. -1.13e+11. What is the difference between the Expenses (in $) of Custom duties in 2006 and the Expenses (in $) of Other expenses in 2010?
Ensure brevity in your answer.  -3.96e+11. What is the difference between the Expenses (in $) of Interest Payments in 2006 and the Expenses (in $) of Other expenses in 2010?
Provide a short and direct response. -3.14e+11. What is the difference between the Expenses (in $) in Salary of employees in 2006 and the Expenses (in $) in Custom duties in 2011?
Your answer should be compact. 2.24e+1. What is the difference between the Expenses (in $) of Salary of employees in 2006 and the Expenses (in $) of Interest Payments in 2011?
Offer a very short reply. -7.93e+1. What is the difference between the Expenses (in $) in Salary of employees in 2006 and the Expenses (in $) in Other expenses in 2011?
Your response must be concise. -3.89e+11. What is the difference between the Expenses (in $) of Custom duties in 2006 and the Expenses (in $) of Interest Payments in 2011?
Provide a short and direct response. -1.05e+11. What is the difference between the Expenses (in $) of Custom duties in 2006 and the Expenses (in $) of Other expenses in 2011?
Your response must be concise. -4.15e+11. What is the difference between the Expenses (in $) of Interest Payments in 2006 and the Expenses (in $) of Other expenses in 2011?
Your answer should be compact. -3.33e+11. What is the difference between the Expenses (in $) in Salary of employees in 2006 and the Expenses (in $) in Custom duties in 2012?
Offer a terse response. 1.82e+1. What is the difference between the Expenses (in $) in Salary of employees in 2006 and the Expenses (in $) in Interest Payments in 2012?
Offer a terse response. -9.53e+1. What is the difference between the Expenses (in $) of Salary of employees in 2006 and the Expenses (in $) of Other expenses in 2012?
Give a very brief answer. -4.05e+11. What is the difference between the Expenses (in $) of Custom duties in 2006 and the Expenses (in $) of Interest Payments in 2012?
Ensure brevity in your answer.  -1.21e+11. What is the difference between the Expenses (in $) of Custom duties in 2006 and the Expenses (in $) of Other expenses in 2012?
Give a very brief answer. -4.31e+11. What is the difference between the Expenses (in $) in Interest Payments in 2006 and the Expenses (in $) in Other expenses in 2012?
Provide a short and direct response. -3.49e+11. What is the difference between the Expenses (in $) in Salary of employees in 2007 and the Expenses (in $) in Custom duties in 2008?
Your answer should be very brief. 2.68e+1. What is the difference between the Expenses (in $) in Salary of employees in 2007 and the Expenses (in $) in Interest Payments in 2008?
Ensure brevity in your answer.  -7.87e+1. What is the difference between the Expenses (in $) in Salary of employees in 2007 and the Expenses (in $) in Other expenses in 2008?
Give a very brief answer. -3.08e+11. What is the difference between the Expenses (in $) in Custom duties in 2007 and the Expenses (in $) in Interest Payments in 2008?
Offer a very short reply. -1.07e+11. What is the difference between the Expenses (in $) of Custom duties in 2007 and the Expenses (in $) of Other expenses in 2008?
Keep it short and to the point. -3.36e+11. What is the difference between the Expenses (in $) of Interest Payments in 2007 and the Expenses (in $) of Other expenses in 2008?
Offer a terse response. -2.50e+11. What is the difference between the Expenses (in $) of Salary of employees in 2007 and the Expenses (in $) of Custom duties in 2009?
Offer a very short reply. 2.87e+1. What is the difference between the Expenses (in $) in Salary of employees in 2007 and the Expenses (in $) in Interest Payments in 2009?
Provide a short and direct response. -1.42e+11. What is the difference between the Expenses (in $) in Salary of employees in 2007 and the Expenses (in $) in Other expenses in 2009?
Ensure brevity in your answer.  -3.91e+11. What is the difference between the Expenses (in $) of Custom duties in 2007 and the Expenses (in $) of Interest Payments in 2009?
Give a very brief answer. -1.71e+11. What is the difference between the Expenses (in $) in Custom duties in 2007 and the Expenses (in $) in Other expenses in 2009?
Offer a terse response. -4.20e+11. What is the difference between the Expenses (in $) of Interest Payments in 2007 and the Expenses (in $) of Other expenses in 2009?
Provide a succinct answer. -3.34e+11. What is the difference between the Expenses (in $) in Salary of employees in 2007 and the Expenses (in $) in Custom duties in 2010?
Ensure brevity in your answer.  2.70e+1. What is the difference between the Expenses (in $) in Salary of employees in 2007 and the Expenses (in $) in Interest Payments in 2010?
Make the answer very short. -8.18e+1. What is the difference between the Expenses (in $) in Salary of employees in 2007 and the Expenses (in $) in Other expenses in 2010?
Your answer should be very brief. -3.65e+11. What is the difference between the Expenses (in $) of Custom duties in 2007 and the Expenses (in $) of Interest Payments in 2010?
Your answer should be compact. -1.10e+11. What is the difference between the Expenses (in $) of Custom duties in 2007 and the Expenses (in $) of Other expenses in 2010?
Provide a succinct answer. -3.93e+11. What is the difference between the Expenses (in $) of Interest Payments in 2007 and the Expenses (in $) of Other expenses in 2010?
Your response must be concise. -3.07e+11. What is the difference between the Expenses (in $) of Salary of employees in 2007 and the Expenses (in $) of Custom duties in 2011?
Give a very brief answer. 2.75e+1. What is the difference between the Expenses (in $) in Salary of employees in 2007 and the Expenses (in $) in Interest Payments in 2011?
Your response must be concise. -7.42e+1. What is the difference between the Expenses (in $) of Salary of employees in 2007 and the Expenses (in $) of Other expenses in 2011?
Ensure brevity in your answer.  -3.84e+11. What is the difference between the Expenses (in $) of Custom duties in 2007 and the Expenses (in $) of Interest Payments in 2011?
Provide a short and direct response. -1.03e+11. What is the difference between the Expenses (in $) in Custom duties in 2007 and the Expenses (in $) in Other expenses in 2011?
Your answer should be very brief. -4.12e+11. What is the difference between the Expenses (in $) in Interest Payments in 2007 and the Expenses (in $) in Other expenses in 2011?
Keep it short and to the point. -3.26e+11. What is the difference between the Expenses (in $) of Salary of employees in 2007 and the Expenses (in $) of Custom duties in 2012?
Your answer should be very brief. 2.34e+1. What is the difference between the Expenses (in $) of Salary of employees in 2007 and the Expenses (in $) of Interest Payments in 2012?
Your answer should be compact. -9.01e+1. What is the difference between the Expenses (in $) of Salary of employees in 2007 and the Expenses (in $) of Other expenses in 2012?
Provide a short and direct response. -4.00e+11. What is the difference between the Expenses (in $) of Custom duties in 2007 and the Expenses (in $) of Interest Payments in 2012?
Keep it short and to the point. -1.19e+11. What is the difference between the Expenses (in $) in Custom duties in 2007 and the Expenses (in $) in Other expenses in 2012?
Provide a succinct answer. -4.28e+11. What is the difference between the Expenses (in $) in Interest Payments in 2007 and the Expenses (in $) in Other expenses in 2012?
Keep it short and to the point. -3.42e+11. What is the difference between the Expenses (in $) in Salary of employees in 2008 and the Expenses (in $) in Custom duties in 2009?
Your answer should be very brief. 3.99e+1. What is the difference between the Expenses (in $) in Salary of employees in 2008 and the Expenses (in $) in Interest Payments in 2009?
Ensure brevity in your answer.  -1.31e+11. What is the difference between the Expenses (in $) in Salary of employees in 2008 and the Expenses (in $) in Other expenses in 2009?
Keep it short and to the point. -3.80e+11. What is the difference between the Expenses (in $) in Custom duties in 2008 and the Expenses (in $) in Interest Payments in 2009?
Provide a succinct answer. -1.69e+11. What is the difference between the Expenses (in $) in Custom duties in 2008 and the Expenses (in $) in Other expenses in 2009?
Keep it short and to the point. -4.18e+11. What is the difference between the Expenses (in $) in Interest Payments in 2008 and the Expenses (in $) in Other expenses in 2009?
Your answer should be very brief. -3.13e+11. What is the difference between the Expenses (in $) of Salary of employees in 2008 and the Expenses (in $) of Custom duties in 2010?
Give a very brief answer. 3.82e+1. What is the difference between the Expenses (in $) in Salary of employees in 2008 and the Expenses (in $) in Interest Payments in 2010?
Your answer should be compact. -7.06e+1. What is the difference between the Expenses (in $) in Salary of employees in 2008 and the Expenses (in $) in Other expenses in 2010?
Your response must be concise. -3.54e+11. What is the difference between the Expenses (in $) in Custom duties in 2008 and the Expenses (in $) in Interest Payments in 2010?
Keep it short and to the point. -1.09e+11. What is the difference between the Expenses (in $) of Custom duties in 2008 and the Expenses (in $) of Other expenses in 2010?
Make the answer very short. -3.92e+11. What is the difference between the Expenses (in $) in Interest Payments in 2008 and the Expenses (in $) in Other expenses in 2010?
Your answer should be very brief. -2.86e+11. What is the difference between the Expenses (in $) in Salary of employees in 2008 and the Expenses (in $) in Custom duties in 2011?
Offer a terse response. 3.88e+1. What is the difference between the Expenses (in $) in Salary of employees in 2008 and the Expenses (in $) in Interest Payments in 2011?
Provide a short and direct response. -6.29e+1. What is the difference between the Expenses (in $) in Salary of employees in 2008 and the Expenses (in $) in Other expenses in 2011?
Your answer should be compact. -3.73e+11. What is the difference between the Expenses (in $) of Custom duties in 2008 and the Expenses (in $) of Interest Payments in 2011?
Your answer should be compact. -1.01e+11. What is the difference between the Expenses (in $) in Custom duties in 2008 and the Expenses (in $) in Other expenses in 2011?
Your answer should be compact. -4.11e+11. What is the difference between the Expenses (in $) of Interest Payments in 2008 and the Expenses (in $) of Other expenses in 2011?
Keep it short and to the point. -3.05e+11. What is the difference between the Expenses (in $) of Salary of employees in 2008 and the Expenses (in $) of Custom duties in 2012?
Keep it short and to the point. 3.47e+1. What is the difference between the Expenses (in $) in Salary of employees in 2008 and the Expenses (in $) in Interest Payments in 2012?
Provide a short and direct response. -7.89e+1. What is the difference between the Expenses (in $) in Salary of employees in 2008 and the Expenses (in $) in Other expenses in 2012?
Provide a short and direct response. -3.89e+11. What is the difference between the Expenses (in $) in Custom duties in 2008 and the Expenses (in $) in Interest Payments in 2012?
Your answer should be compact. -1.17e+11. What is the difference between the Expenses (in $) of Custom duties in 2008 and the Expenses (in $) of Other expenses in 2012?
Your response must be concise. -4.27e+11. What is the difference between the Expenses (in $) in Interest Payments in 2008 and the Expenses (in $) in Other expenses in 2012?
Keep it short and to the point. -3.21e+11. What is the difference between the Expenses (in $) in Salary of employees in 2009 and the Expenses (in $) in Custom duties in 2010?
Your answer should be very brief. 4.44e+1. What is the difference between the Expenses (in $) of Salary of employees in 2009 and the Expenses (in $) of Interest Payments in 2010?
Give a very brief answer. -6.44e+1. What is the difference between the Expenses (in $) in Salary of employees in 2009 and the Expenses (in $) in Other expenses in 2010?
Your response must be concise. -3.47e+11. What is the difference between the Expenses (in $) in Custom duties in 2009 and the Expenses (in $) in Interest Payments in 2010?
Keep it short and to the point. -1.11e+11. What is the difference between the Expenses (in $) of Custom duties in 2009 and the Expenses (in $) of Other expenses in 2010?
Your answer should be very brief. -3.93e+11. What is the difference between the Expenses (in $) of Interest Payments in 2009 and the Expenses (in $) of Other expenses in 2010?
Offer a terse response. -2.23e+11. What is the difference between the Expenses (in $) of Salary of employees in 2009 and the Expenses (in $) of Custom duties in 2011?
Keep it short and to the point. 4.49e+1. What is the difference between the Expenses (in $) of Salary of employees in 2009 and the Expenses (in $) of Interest Payments in 2011?
Provide a short and direct response. -5.68e+1. What is the difference between the Expenses (in $) in Salary of employees in 2009 and the Expenses (in $) in Other expenses in 2011?
Offer a terse response. -3.66e+11. What is the difference between the Expenses (in $) of Custom duties in 2009 and the Expenses (in $) of Interest Payments in 2011?
Give a very brief answer. -1.03e+11. What is the difference between the Expenses (in $) in Custom duties in 2009 and the Expenses (in $) in Other expenses in 2011?
Offer a terse response. -4.13e+11. What is the difference between the Expenses (in $) of Interest Payments in 2009 and the Expenses (in $) of Other expenses in 2011?
Make the answer very short. -2.42e+11. What is the difference between the Expenses (in $) in Salary of employees in 2009 and the Expenses (in $) in Custom duties in 2012?
Ensure brevity in your answer.  4.08e+1. What is the difference between the Expenses (in $) of Salary of employees in 2009 and the Expenses (in $) of Interest Payments in 2012?
Your answer should be very brief. -7.27e+1. What is the difference between the Expenses (in $) of Salary of employees in 2009 and the Expenses (in $) of Other expenses in 2012?
Offer a terse response. -3.82e+11. What is the difference between the Expenses (in $) of Custom duties in 2009 and the Expenses (in $) of Interest Payments in 2012?
Offer a terse response. -1.19e+11. What is the difference between the Expenses (in $) of Custom duties in 2009 and the Expenses (in $) of Other expenses in 2012?
Offer a terse response. -4.29e+11. What is the difference between the Expenses (in $) in Interest Payments in 2009 and the Expenses (in $) in Other expenses in 2012?
Provide a succinct answer. -2.58e+11. What is the difference between the Expenses (in $) of Salary of employees in 2010 and the Expenses (in $) of Custom duties in 2011?
Your response must be concise. 4.85e+1. What is the difference between the Expenses (in $) in Salary of employees in 2010 and the Expenses (in $) in Interest Payments in 2011?
Provide a succinct answer. -5.32e+1. What is the difference between the Expenses (in $) of Salary of employees in 2010 and the Expenses (in $) of Other expenses in 2011?
Provide a short and direct response. -3.63e+11. What is the difference between the Expenses (in $) of Custom duties in 2010 and the Expenses (in $) of Interest Payments in 2011?
Provide a short and direct response. -1.01e+11. What is the difference between the Expenses (in $) in Custom duties in 2010 and the Expenses (in $) in Other expenses in 2011?
Your answer should be very brief. -4.11e+11. What is the difference between the Expenses (in $) in Interest Payments in 2010 and the Expenses (in $) in Other expenses in 2011?
Keep it short and to the point. -3.02e+11. What is the difference between the Expenses (in $) of Salary of employees in 2010 and the Expenses (in $) of Custom duties in 2012?
Your answer should be very brief. 4.44e+1. What is the difference between the Expenses (in $) of Salary of employees in 2010 and the Expenses (in $) of Interest Payments in 2012?
Offer a very short reply. -6.92e+1. What is the difference between the Expenses (in $) of Salary of employees in 2010 and the Expenses (in $) of Other expenses in 2012?
Offer a terse response. -3.79e+11. What is the difference between the Expenses (in $) in Custom duties in 2010 and the Expenses (in $) in Interest Payments in 2012?
Make the answer very short. -1.17e+11. What is the difference between the Expenses (in $) in Custom duties in 2010 and the Expenses (in $) in Other expenses in 2012?
Your response must be concise. -4.27e+11. What is the difference between the Expenses (in $) in Interest Payments in 2010 and the Expenses (in $) in Other expenses in 2012?
Ensure brevity in your answer.  -3.18e+11. What is the difference between the Expenses (in $) of Salary of employees in 2011 and the Expenses (in $) of Custom duties in 2012?
Your answer should be compact. 5.22e+1. What is the difference between the Expenses (in $) in Salary of employees in 2011 and the Expenses (in $) in Interest Payments in 2012?
Offer a terse response. -6.14e+1. What is the difference between the Expenses (in $) of Salary of employees in 2011 and the Expenses (in $) of Other expenses in 2012?
Keep it short and to the point. -3.71e+11. What is the difference between the Expenses (in $) in Custom duties in 2011 and the Expenses (in $) in Interest Payments in 2012?
Your answer should be very brief. -1.18e+11. What is the difference between the Expenses (in $) in Custom duties in 2011 and the Expenses (in $) in Other expenses in 2012?
Provide a short and direct response. -4.27e+11. What is the difference between the Expenses (in $) in Interest Payments in 2011 and the Expenses (in $) in Other expenses in 2012?
Keep it short and to the point. -3.26e+11. What is the average Expenses (in $) in Salary of employees per year?
Your response must be concise. 5.56e+1. What is the average Expenses (in $) of Custom duties per year?
Keep it short and to the point. 1.89e+1. What is the average Expenses (in $) of Interest Payments per year?
Ensure brevity in your answer.  1.21e+11. What is the average Expenses (in $) of Other expenses per year?
Ensure brevity in your answer.  3.41e+11. In the year 2004, what is the difference between the Expenses (in $) of Salary of employees and Expenses (in $) of Custom duties?
Give a very brief answer. 1.66e+1. In the year 2004, what is the difference between the Expenses (in $) of Salary of employees and Expenses (in $) of Interest Payments?
Offer a terse response. -6.42e+1. In the year 2004, what is the difference between the Expenses (in $) of Salary of employees and Expenses (in $) of Other expenses?
Keep it short and to the point. -1.83e+11. In the year 2004, what is the difference between the Expenses (in $) in Custom duties and Expenses (in $) in Interest Payments?
Your response must be concise. -8.08e+1. In the year 2004, what is the difference between the Expenses (in $) of Custom duties and Expenses (in $) of Other expenses?
Your response must be concise. -2.00e+11. In the year 2004, what is the difference between the Expenses (in $) in Interest Payments and Expenses (in $) in Other expenses?
Offer a very short reply. -1.19e+11. In the year 2005, what is the difference between the Expenses (in $) in Salary of employees and Expenses (in $) in Custom duties?
Your answer should be compact. 1.86e+1. In the year 2005, what is the difference between the Expenses (in $) in Salary of employees and Expenses (in $) in Interest Payments?
Offer a terse response. -5.17e+1. In the year 2005, what is the difference between the Expenses (in $) in Salary of employees and Expenses (in $) in Other expenses?
Keep it short and to the point. -1.81e+11. In the year 2005, what is the difference between the Expenses (in $) of Custom duties and Expenses (in $) of Interest Payments?
Offer a very short reply. -7.03e+1. In the year 2005, what is the difference between the Expenses (in $) in Custom duties and Expenses (in $) in Other expenses?
Offer a very short reply. -2.00e+11. In the year 2005, what is the difference between the Expenses (in $) in Interest Payments and Expenses (in $) in Other expenses?
Offer a terse response. -1.30e+11. In the year 2006, what is the difference between the Expenses (in $) of Salary of employees and Expenses (in $) of Custom duties?
Keep it short and to the point. 2.55e+1. In the year 2006, what is the difference between the Expenses (in $) in Salary of employees and Expenses (in $) in Interest Payments?
Give a very brief answer. -5.59e+1. In the year 2006, what is the difference between the Expenses (in $) in Salary of employees and Expenses (in $) in Other expenses?
Your answer should be very brief. -2.12e+11. In the year 2006, what is the difference between the Expenses (in $) in Custom duties and Expenses (in $) in Interest Payments?
Provide a short and direct response. -8.15e+1. In the year 2006, what is the difference between the Expenses (in $) in Custom duties and Expenses (in $) in Other expenses?
Provide a succinct answer. -2.38e+11. In the year 2006, what is the difference between the Expenses (in $) in Interest Payments and Expenses (in $) in Other expenses?
Your answer should be compact. -1.56e+11. In the year 2007, what is the difference between the Expenses (in $) of Salary of employees and Expenses (in $) of Custom duties?
Ensure brevity in your answer.  2.84e+1. In the year 2007, what is the difference between the Expenses (in $) in Salary of employees and Expenses (in $) in Interest Payments?
Give a very brief answer. -5.74e+1. In the year 2007, what is the difference between the Expenses (in $) in Salary of employees and Expenses (in $) in Other expenses?
Your answer should be very brief. -2.56e+11. In the year 2007, what is the difference between the Expenses (in $) of Custom duties and Expenses (in $) of Interest Payments?
Provide a short and direct response. -8.58e+1. In the year 2007, what is the difference between the Expenses (in $) in Custom duties and Expenses (in $) in Other expenses?
Your answer should be compact. -2.84e+11. In the year 2007, what is the difference between the Expenses (in $) of Interest Payments and Expenses (in $) of Other expenses?
Give a very brief answer. -1.98e+11. In the year 2008, what is the difference between the Expenses (in $) of Salary of employees and Expenses (in $) of Custom duties?
Provide a short and direct response. 3.81e+1. In the year 2008, what is the difference between the Expenses (in $) in Salary of employees and Expenses (in $) in Interest Payments?
Offer a very short reply. -6.74e+1. In the year 2008, what is the difference between the Expenses (in $) in Salary of employees and Expenses (in $) in Other expenses?
Make the answer very short. -2.97e+11. In the year 2008, what is the difference between the Expenses (in $) of Custom duties and Expenses (in $) of Interest Payments?
Give a very brief answer. -1.05e+11. In the year 2008, what is the difference between the Expenses (in $) of Custom duties and Expenses (in $) of Other expenses?
Make the answer very short. -3.35e+11. In the year 2008, what is the difference between the Expenses (in $) in Interest Payments and Expenses (in $) in Other expenses?
Your answer should be very brief. -2.29e+11. In the year 2009, what is the difference between the Expenses (in $) of Salary of employees and Expenses (in $) of Custom duties?
Provide a succinct answer. 4.61e+1. In the year 2009, what is the difference between the Expenses (in $) of Salary of employees and Expenses (in $) of Interest Payments?
Provide a short and direct response. -1.25e+11. In the year 2009, what is the difference between the Expenses (in $) in Salary of employees and Expenses (in $) in Other expenses?
Ensure brevity in your answer.  -3.74e+11. In the year 2009, what is the difference between the Expenses (in $) of Custom duties and Expenses (in $) of Interest Payments?
Your answer should be very brief. -1.71e+11. In the year 2009, what is the difference between the Expenses (in $) in Custom duties and Expenses (in $) in Other expenses?
Provide a succinct answer. -4.20e+11. In the year 2009, what is the difference between the Expenses (in $) of Interest Payments and Expenses (in $) of Other expenses?
Provide a short and direct response. -2.49e+11. In the year 2010, what is the difference between the Expenses (in $) of Salary of employees and Expenses (in $) of Custom duties?
Your answer should be very brief. 4.80e+1. In the year 2010, what is the difference between the Expenses (in $) of Salary of employees and Expenses (in $) of Interest Payments?
Provide a short and direct response. -6.08e+1. In the year 2010, what is the difference between the Expenses (in $) of Salary of employees and Expenses (in $) of Other expenses?
Your response must be concise. -3.44e+11. In the year 2010, what is the difference between the Expenses (in $) in Custom duties and Expenses (in $) in Interest Payments?
Make the answer very short. -1.09e+11. In the year 2010, what is the difference between the Expenses (in $) in Custom duties and Expenses (in $) in Other expenses?
Provide a succinct answer. -3.92e+11. In the year 2010, what is the difference between the Expenses (in $) in Interest Payments and Expenses (in $) in Other expenses?
Offer a terse response. -2.83e+11. In the year 2011, what is the difference between the Expenses (in $) in Salary of employees and Expenses (in $) in Custom duties?
Your answer should be compact. 5.63e+1. In the year 2011, what is the difference between the Expenses (in $) of Salary of employees and Expenses (in $) of Interest Payments?
Your answer should be compact. -4.54e+1. In the year 2011, what is the difference between the Expenses (in $) of Salary of employees and Expenses (in $) of Other expenses?
Keep it short and to the point. -3.55e+11. In the year 2011, what is the difference between the Expenses (in $) of Custom duties and Expenses (in $) of Interest Payments?
Offer a terse response. -1.02e+11. In the year 2011, what is the difference between the Expenses (in $) of Custom duties and Expenses (in $) of Other expenses?
Your answer should be very brief. -4.11e+11. In the year 2011, what is the difference between the Expenses (in $) in Interest Payments and Expenses (in $) in Other expenses?
Your answer should be very brief. -3.10e+11. In the year 2012, what is the difference between the Expenses (in $) of Salary of employees and Expenses (in $) of Custom duties?
Offer a very short reply. 5.26e+1. In the year 2012, what is the difference between the Expenses (in $) of Salary of employees and Expenses (in $) of Interest Payments?
Offer a terse response. -6.10e+1. In the year 2012, what is the difference between the Expenses (in $) of Salary of employees and Expenses (in $) of Other expenses?
Give a very brief answer. -3.71e+11. In the year 2012, what is the difference between the Expenses (in $) in Custom duties and Expenses (in $) in Interest Payments?
Offer a terse response. -1.14e+11. In the year 2012, what is the difference between the Expenses (in $) in Custom duties and Expenses (in $) in Other expenses?
Make the answer very short. -4.23e+11. In the year 2012, what is the difference between the Expenses (in $) of Interest Payments and Expenses (in $) of Other expenses?
Provide a short and direct response. -3.10e+11. What is the ratio of the Expenses (in $) in Salary of employees in 2004 to that in 2005?
Your response must be concise. 0.9. What is the ratio of the Expenses (in $) in Custom duties in 2004 to that in 2005?
Your response must be concise. 0.9. What is the ratio of the Expenses (in $) of Interest Payments in 2004 to that in 2005?
Keep it short and to the point. 1.1. What is the ratio of the Expenses (in $) in Salary of employees in 2004 to that in 2006?
Give a very brief answer. 0.72. What is the ratio of the Expenses (in $) of Custom duties in 2004 to that in 2006?
Your answer should be very brief. 0.82. What is the ratio of the Expenses (in $) of Interest Payments in 2004 to that in 2006?
Provide a succinct answer. 0.96. What is the ratio of the Expenses (in $) in Other expenses in 2004 to that in 2006?
Make the answer very short. 0.84. What is the ratio of the Expenses (in $) in Salary of employees in 2004 to that in 2007?
Offer a very short reply. 0.64. What is the ratio of the Expenses (in $) in Custom duties in 2004 to that in 2007?
Keep it short and to the point. 0.72. What is the ratio of the Expenses (in $) in Interest Payments in 2004 to that in 2007?
Give a very brief answer. 0.9. What is the ratio of the Expenses (in $) in Other expenses in 2004 to that in 2007?
Your answer should be compact. 0.7. What is the ratio of the Expenses (in $) of Salary of employees in 2004 to that in 2008?
Your response must be concise. 0.52. What is the ratio of the Expenses (in $) in Custom duties in 2004 to that in 2008?
Make the answer very short. 0.66. What is the ratio of the Expenses (in $) in Interest Payments in 2004 to that in 2008?
Make the answer very short. 0.75. What is the ratio of the Expenses (in $) in Other expenses in 2004 to that in 2008?
Your answer should be compact. 0.6. What is the ratio of the Expenses (in $) in Salary of employees in 2004 to that in 2009?
Provide a succinct answer. 0.47. What is the ratio of the Expenses (in $) in Custom duties in 2004 to that in 2009?
Provide a succinct answer. 0.73. What is the ratio of the Expenses (in $) in Interest Payments in 2004 to that in 2009?
Give a very brief answer. 0.5. What is the ratio of the Expenses (in $) in Other expenses in 2004 to that in 2009?
Your answer should be compact. 0.49. What is the ratio of the Expenses (in $) of Salary of employees in 2004 to that in 2010?
Ensure brevity in your answer.  0.44. What is the ratio of the Expenses (in $) of Custom duties in 2004 to that in 2010?
Keep it short and to the point. 0.67. What is the ratio of the Expenses (in $) in Interest Payments in 2004 to that in 2010?
Your response must be concise. 0.73. What is the ratio of the Expenses (in $) of Other expenses in 2004 to that in 2010?
Your answer should be very brief. 0.52. What is the ratio of the Expenses (in $) in Salary of employees in 2004 to that in 2011?
Your response must be concise. 0.4. What is the ratio of the Expenses (in $) in Custom duties in 2004 to that in 2011?
Make the answer very short. 0.69. What is the ratio of the Expenses (in $) of Interest Payments in 2004 to that in 2011?
Make the answer very short. 0.78. What is the ratio of the Expenses (in $) in Other expenses in 2004 to that in 2011?
Offer a terse response. 0.49. What is the ratio of the Expenses (in $) in Salary of employees in 2004 to that in 2012?
Offer a very short reply. 0.4. What is the ratio of the Expenses (in $) in Custom duties in 2004 to that in 2012?
Make the answer very short. 0.57. What is the ratio of the Expenses (in $) of Interest Payments in 2004 to that in 2012?
Your answer should be very brief. 0.69. What is the ratio of the Expenses (in $) of Other expenses in 2004 to that in 2012?
Your answer should be very brief. 0.48. What is the ratio of the Expenses (in $) in Salary of employees in 2005 to that in 2006?
Offer a terse response. 0.8. What is the ratio of the Expenses (in $) in Custom duties in 2005 to that in 2006?
Offer a terse response. 0.91. What is the ratio of the Expenses (in $) of Interest Payments in 2005 to that in 2006?
Make the answer very short. 0.87. What is the ratio of the Expenses (in $) in Other expenses in 2005 to that in 2006?
Provide a short and direct response. 0.85. What is the ratio of the Expenses (in $) of Salary of employees in 2005 to that in 2007?
Your answer should be compact. 0.71. What is the ratio of the Expenses (in $) in Custom duties in 2005 to that in 2007?
Offer a very short reply. 0.8. What is the ratio of the Expenses (in $) of Interest Payments in 2005 to that in 2007?
Keep it short and to the point. 0.82. What is the ratio of the Expenses (in $) in Other expenses in 2005 to that in 2007?
Provide a short and direct response. 0.71. What is the ratio of the Expenses (in $) of Salary of employees in 2005 to that in 2008?
Provide a short and direct response. 0.58. What is the ratio of the Expenses (in $) of Custom duties in 2005 to that in 2008?
Keep it short and to the point. 0.74. What is the ratio of the Expenses (in $) in Interest Payments in 2005 to that in 2008?
Ensure brevity in your answer.  0.68. What is the ratio of the Expenses (in $) in Other expenses in 2005 to that in 2008?
Give a very brief answer. 0.61. What is the ratio of the Expenses (in $) of Salary of employees in 2005 to that in 2009?
Your answer should be compact. 0.52. What is the ratio of the Expenses (in $) of Custom duties in 2005 to that in 2009?
Your answer should be compact. 0.81. What is the ratio of the Expenses (in $) of Interest Payments in 2005 to that in 2009?
Keep it short and to the point. 0.45. What is the ratio of the Expenses (in $) in Other expenses in 2005 to that in 2009?
Provide a short and direct response. 0.49. What is the ratio of the Expenses (in $) of Salary of employees in 2005 to that in 2010?
Offer a terse response. 0.49. What is the ratio of the Expenses (in $) of Custom duties in 2005 to that in 2010?
Offer a very short reply. 0.75. What is the ratio of the Expenses (in $) in Interest Payments in 2005 to that in 2010?
Offer a terse response. 0.66. What is the ratio of the Expenses (in $) of Other expenses in 2005 to that in 2010?
Give a very brief answer. 0.52. What is the ratio of the Expenses (in $) of Salary of employees in 2005 to that in 2011?
Your response must be concise. 0.44. What is the ratio of the Expenses (in $) in Custom duties in 2005 to that in 2011?
Your response must be concise. 0.77. What is the ratio of the Expenses (in $) of Interest Payments in 2005 to that in 2011?
Keep it short and to the point. 0.7. What is the ratio of the Expenses (in $) of Other expenses in 2005 to that in 2011?
Give a very brief answer. 0.5. What is the ratio of the Expenses (in $) of Salary of employees in 2005 to that in 2012?
Offer a terse response. 0.44. What is the ratio of the Expenses (in $) in Custom duties in 2005 to that in 2012?
Offer a terse response. 0.64. What is the ratio of the Expenses (in $) of Interest Payments in 2005 to that in 2012?
Your response must be concise. 0.62. What is the ratio of the Expenses (in $) of Other expenses in 2005 to that in 2012?
Your answer should be very brief. 0.48. What is the ratio of the Expenses (in $) of Salary of employees in 2006 to that in 2007?
Give a very brief answer. 0.89. What is the ratio of the Expenses (in $) of Custom duties in 2006 to that in 2007?
Ensure brevity in your answer.  0.88. What is the ratio of the Expenses (in $) of Interest Payments in 2006 to that in 2007?
Provide a short and direct response. 0.94. What is the ratio of the Expenses (in $) of Other expenses in 2006 to that in 2007?
Ensure brevity in your answer.  0.84. What is the ratio of the Expenses (in $) in Salary of employees in 2006 to that in 2008?
Keep it short and to the point. 0.72. What is the ratio of the Expenses (in $) of Custom duties in 2006 to that in 2008?
Ensure brevity in your answer.  0.81. What is the ratio of the Expenses (in $) of Interest Payments in 2006 to that in 2008?
Your answer should be compact. 0.78. What is the ratio of the Expenses (in $) of Other expenses in 2006 to that in 2008?
Your response must be concise. 0.72. What is the ratio of the Expenses (in $) of Salary of employees in 2006 to that in 2009?
Keep it short and to the point. 0.65. What is the ratio of the Expenses (in $) of Custom duties in 2006 to that in 2009?
Ensure brevity in your answer.  0.89. What is the ratio of the Expenses (in $) in Interest Payments in 2006 to that in 2009?
Offer a very short reply. 0.52. What is the ratio of the Expenses (in $) of Other expenses in 2006 to that in 2009?
Provide a short and direct response. 0.58. What is the ratio of the Expenses (in $) in Salary of employees in 2006 to that in 2010?
Offer a very short reply. 0.62. What is the ratio of the Expenses (in $) in Custom duties in 2006 to that in 2010?
Offer a terse response. 0.82. What is the ratio of the Expenses (in $) in Interest Payments in 2006 to that in 2010?
Ensure brevity in your answer.  0.76. What is the ratio of the Expenses (in $) of Other expenses in 2006 to that in 2010?
Ensure brevity in your answer.  0.62. What is the ratio of the Expenses (in $) of Salary of employees in 2006 to that in 2011?
Offer a terse response. 0.56. What is the ratio of the Expenses (in $) in Custom duties in 2006 to that in 2011?
Give a very brief answer. 0.84. What is the ratio of the Expenses (in $) of Interest Payments in 2006 to that in 2011?
Keep it short and to the point. 0.81. What is the ratio of the Expenses (in $) of Other expenses in 2006 to that in 2011?
Provide a short and direct response. 0.59. What is the ratio of the Expenses (in $) of Salary of employees in 2006 to that in 2012?
Make the answer very short. 0.55. What is the ratio of the Expenses (in $) of Custom duties in 2006 to that in 2012?
Give a very brief answer. 0.7. What is the ratio of the Expenses (in $) of Interest Payments in 2006 to that in 2012?
Offer a very short reply. 0.71. What is the ratio of the Expenses (in $) in Other expenses in 2006 to that in 2012?
Give a very brief answer. 0.57. What is the ratio of the Expenses (in $) of Salary of employees in 2007 to that in 2008?
Give a very brief answer. 0.81. What is the ratio of the Expenses (in $) in Custom duties in 2007 to that in 2008?
Give a very brief answer. 0.92. What is the ratio of the Expenses (in $) of Interest Payments in 2007 to that in 2008?
Offer a very short reply. 0.83. What is the ratio of the Expenses (in $) of Other expenses in 2007 to that in 2008?
Offer a terse response. 0.85. What is the ratio of the Expenses (in $) in Salary of employees in 2007 to that in 2009?
Your response must be concise. 0.73. What is the ratio of the Expenses (in $) in Custom duties in 2007 to that in 2009?
Your answer should be very brief. 1.01. What is the ratio of the Expenses (in $) of Interest Payments in 2007 to that in 2009?
Your answer should be very brief. 0.55. What is the ratio of the Expenses (in $) of Other expenses in 2007 to that in 2009?
Make the answer very short. 0.69. What is the ratio of the Expenses (in $) of Salary of employees in 2007 to that in 2010?
Keep it short and to the point. 0.69. What is the ratio of the Expenses (in $) of Custom duties in 2007 to that in 2010?
Your answer should be compact. 0.93. What is the ratio of the Expenses (in $) in Interest Payments in 2007 to that in 2010?
Give a very brief answer. 0.81. What is the ratio of the Expenses (in $) of Other expenses in 2007 to that in 2010?
Your answer should be very brief. 0.74. What is the ratio of the Expenses (in $) of Salary of employees in 2007 to that in 2011?
Offer a very short reply. 0.62. What is the ratio of the Expenses (in $) in Custom duties in 2007 to that in 2011?
Offer a terse response. 0.96. What is the ratio of the Expenses (in $) in Interest Payments in 2007 to that in 2011?
Make the answer very short. 0.86. What is the ratio of the Expenses (in $) of Other expenses in 2007 to that in 2011?
Offer a very short reply. 0.7. What is the ratio of the Expenses (in $) in Salary of employees in 2007 to that in 2012?
Provide a succinct answer. 0.62. What is the ratio of the Expenses (in $) in Custom duties in 2007 to that in 2012?
Offer a very short reply. 0.79. What is the ratio of the Expenses (in $) of Interest Payments in 2007 to that in 2012?
Your answer should be very brief. 0.76. What is the ratio of the Expenses (in $) in Other expenses in 2007 to that in 2012?
Your response must be concise. 0.68. What is the ratio of the Expenses (in $) of Salary of employees in 2008 to that in 2009?
Provide a short and direct response. 0.91. What is the ratio of the Expenses (in $) in Custom duties in 2008 to that in 2009?
Offer a terse response. 1.1. What is the ratio of the Expenses (in $) of Interest Payments in 2008 to that in 2009?
Offer a terse response. 0.67. What is the ratio of the Expenses (in $) in Other expenses in 2008 to that in 2009?
Offer a terse response. 0.81. What is the ratio of the Expenses (in $) of Salary of employees in 2008 to that in 2010?
Keep it short and to the point. 0.86. What is the ratio of the Expenses (in $) in Custom duties in 2008 to that in 2010?
Give a very brief answer. 1.01. What is the ratio of the Expenses (in $) in Interest Payments in 2008 to that in 2010?
Your answer should be compact. 0.98. What is the ratio of the Expenses (in $) of Other expenses in 2008 to that in 2010?
Provide a short and direct response. 0.86. What is the ratio of the Expenses (in $) in Salary of employees in 2008 to that in 2011?
Give a very brief answer. 0.77. What is the ratio of the Expenses (in $) of Custom duties in 2008 to that in 2011?
Make the answer very short. 1.04. What is the ratio of the Expenses (in $) of Interest Payments in 2008 to that in 2011?
Offer a very short reply. 1.04. What is the ratio of the Expenses (in $) of Other expenses in 2008 to that in 2011?
Ensure brevity in your answer.  0.82. What is the ratio of the Expenses (in $) of Salary of employees in 2008 to that in 2012?
Keep it short and to the point. 0.77. What is the ratio of the Expenses (in $) in Custom duties in 2008 to that in 2012?
Provide a succinct answer. 0.86. What is the ratio of the Expenses (in $) in Other expenses in 2008 to that in 2012?
Keep it short and to the point. 0.79. What is the ratio of the Expenses (in $) in Salary of employees in 2009 to that in 2010?
Your response must be concise. 0.95. What is the ratio of the Expenses (in $) in Custom duties in 2009 to that in 2010?
Your answer should be compact. 0.92. What is the ratio of the Expenses (in $) of Interest Payments in 2009 to that in 2010?
Ensure brevity in your answer.  1.47. What is the ratio of the Expenses (in $) in Other expenses in 2009 to that in 2010?
Provide a short and direct response. 1.06. What is the ratio of the Expenses (in $) of Salary of employees in 2009 to that in 2011?
Keep it short and to the point. 0.85. What is the ratio of the Expenses (in $) in Custom duties in 2009 to that in 2011?
Give a very brief answer. 0.94. What is the ratio of the Expenses (in $) in Interest Payments in 2009 to that in 2011?
Your response must be concise. 1.56. What is the ratio of the Expenses (in $) of Other expenses in 2009 to that in 2011?
Your answer should be very brief. 1.02. What is the ratio of the Expenses (in $) in Salary of employees in 2009 to that in 2012?
Your response must be concise. 0.85. What is the ratio of the Expenses (in $) in Custom duties in 2009 to that in 2012?
Give a very brief answer. 0.78. What is the ratio of the Expenses (in $) of Interest Payments in 2009 to that in 2012?
Offer a very short reply. 1.38. What is the ratio of the Expenses (in $) of Other expenses in 2009 to that in 2012?
Give a very brief answer. 0.98. What is the ratio of the Expenses (in $) of Salary of employees in 2010 to that in 2011?
Give a very brief answer. 0.9. What is the ratio of the Expenses (in $) in Custom duties in 2010 to that in 2011?
Provide a succinct answer. 1.03. What is the ratio of the Expenses (in $) of Interest Payments in 2010 to that in 2011?
Your response must be concise. 1.06. What is the ratio of the Expenses (in $) in Other expenses in 2010 to that in 2011?
Offer a terse response. 0.96. What is the ratio of the Expenses (in $) in Salary of employees in 2010 to that in 2012?
Give a very brief answer. 0.89. What is the ratio of the Expenses (in $) of Custom duties in 2010 to that in 2012?
Your answer should be very brief. 0.85. What is the ratio of the Expenses (in $) of Interest Payments in 2010 to that in 2012?
Keep it short and to the point. 0.94. What is the ratio of the Expenses (in $) of Other expenses in 2010 to that in 2012?
Ensure brevity in your answer.  0.92. What is the ratio of the Expenses (in $) of Salary of employees in 2011 to that in 2012?
Offer a very short reply. 1. What is the ratio of the Expenses (in $) in Custom duties in 2011 to that in 2012?
Offer a very short reply. 0.83. What is the ratio of the Expenses (in $) in Interest Payments in 2011 to that in 2012?
Your response must be concise. 0.88. What is the ratio of the Expenses (in $) in Other expenses in 2011 to that in 2012?
Keep it short and to the point. 0.96. What is the difference between the highest and the second highest Expenses (in $) of Salary of employees?
Ensure brevity in your answer.  3.74e+08. What is the difference between the highest and the second highest Expenses (in $) of Custom duties?
Give a very brief answer. 3.35e+09. What is the difference between the highest and the second highest Expenses (in $) in Interest Payments?
Your answer should be very brief. 5.21e+1. What is the difference between the highest and the second highest Expenses (in $) in Other expenses?
Provide a short and direct response. 8.36e+09. What is the difference between the highest and the lowest Expenses (in $) of Salary of employees?
Your response must be concise. 4.63e+1. What is the difference between the highest and the lowest Expenses (in $) of Custom duties?
Provide a short and direct response. 1.03e+1. What is the difference between the highest and the lowest Expenses (in $) of Interest Payments?
Provide a succinct answer. 1.04e+11. What is the difference between the highest and the lowest Expenses (in $) in Other expenses?
Provide a succinct answer. 2.34e+11. 